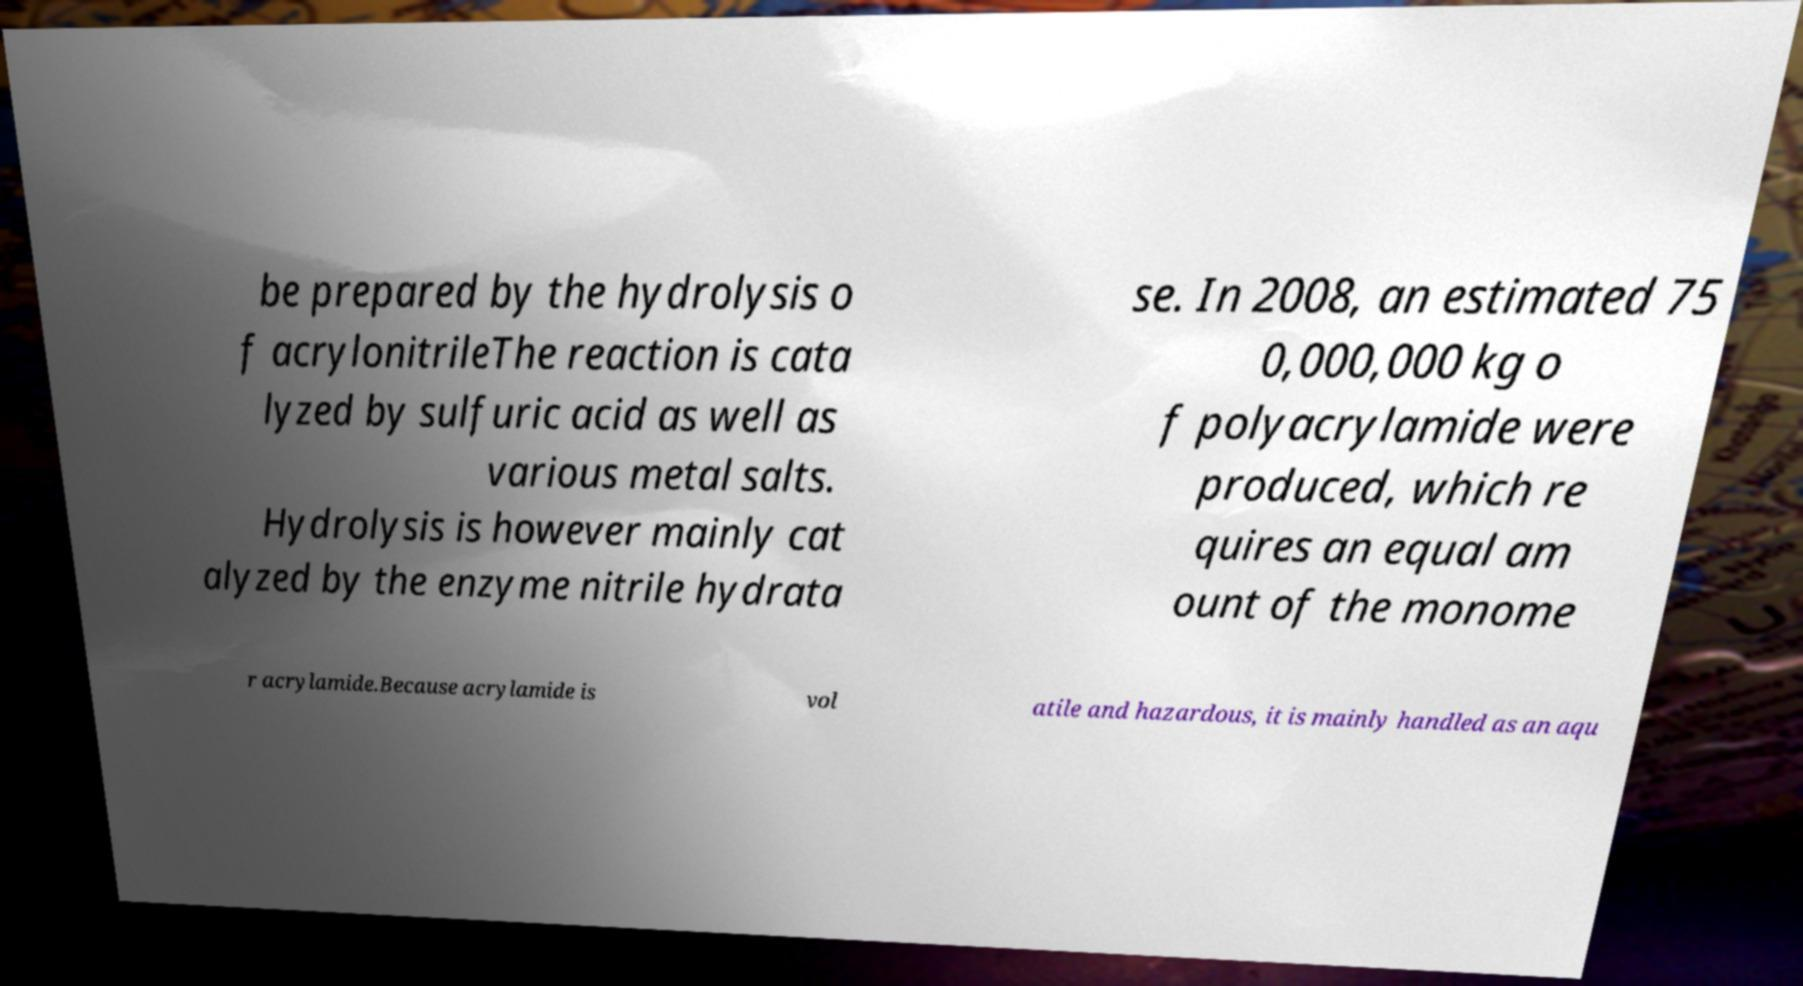What messages or text are displayed in this image? I need them in a readable, typed format. be prepared by the hydrolysis o f acrylonitrileThe reaction is cata lyzed by sulfuric acid as well as various metal salts. Hydrolysis is however mainly cat alyzed by the enzyme nitrile hydrata se. In 2008, an estimated 75 0,000,000 kg o f polyacrylamide were produced, which re quires an equal am ount of the monome r acrylamide.Because acrylamide is vol atile and hazardous, it is mainly handled as an aqu 